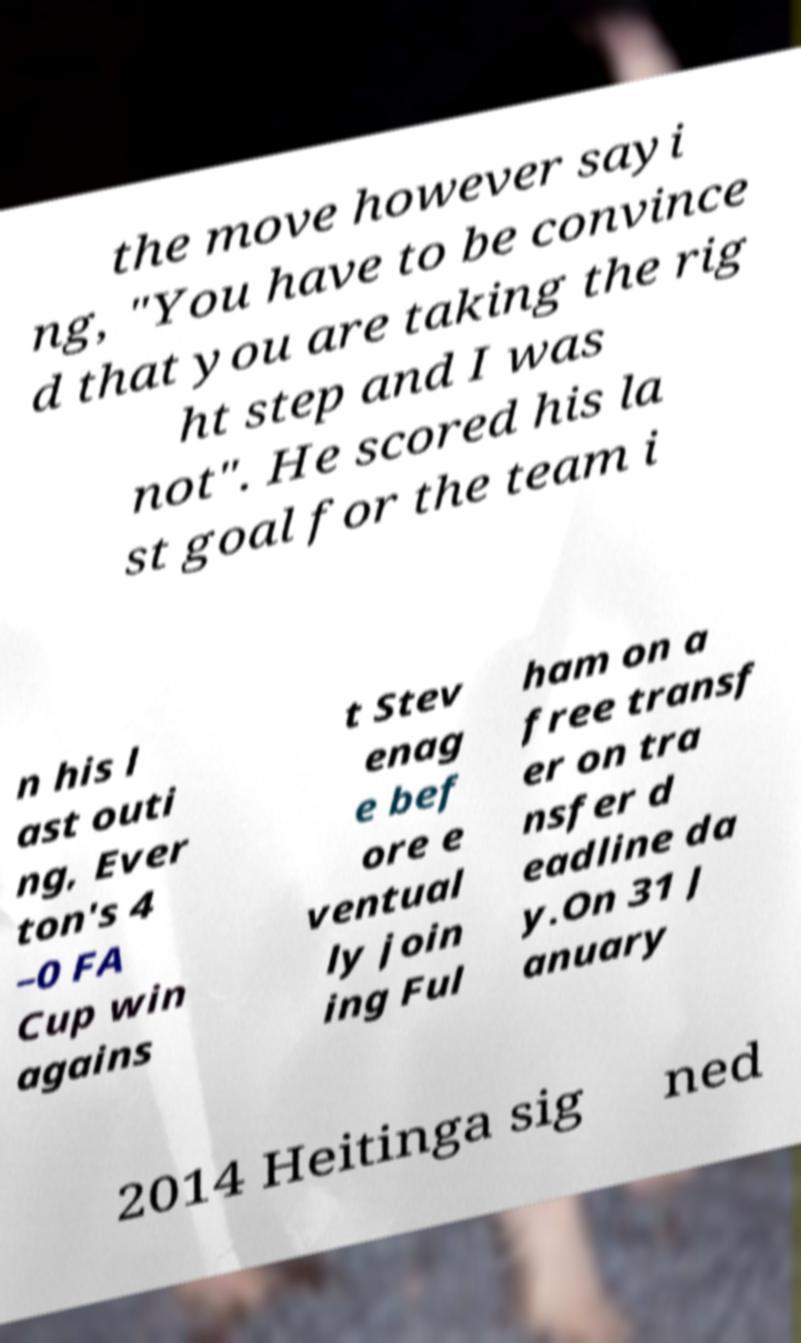Can you accurately transcribe the text from the provided image for me? the move however sayi ng, "You have to be convince d that you are taking the rig ht step and I was not". He scored his la st goal for the team i n his l ast outi ng, Ever ton's 4 –0 FA Cup win agains t Stev enag e bef ore e ventual ly join ing Ful ham on a free transf er on tra nsfer d eadline da y.On 31 J anuary 2014 Heitinga sig ned 